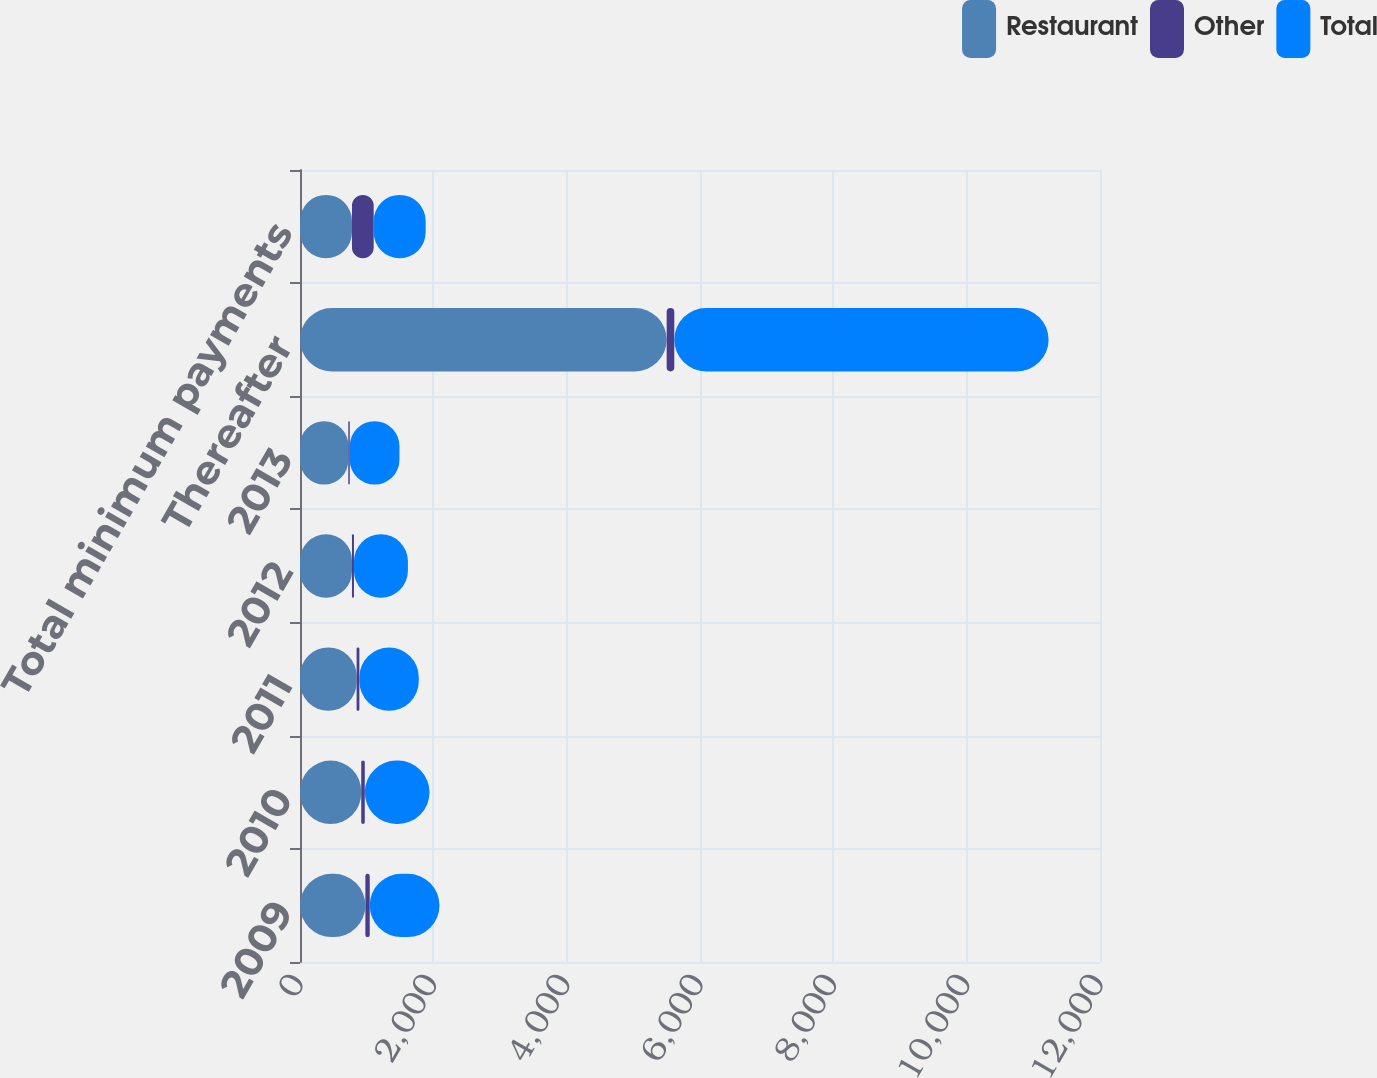<chart> <loc_0><loc_0><loc_500><loc_500><stacked_bar_chart><ecel><fcel>2009<fcel>2010<fcel>2011<fcel>2012<fcel>2013<fcel>Thereafter<fcel>Total minimum payments<nl><fcel>Restaurant<fcel>980.8<fcel>918.7<fcel>849.1<fcel>779.6<fcel>724.5<fcel>5500<fcel>779.6<nl><fcel>Other<fcel>65.3<fcel>52.9<fcel>41.7<fcel>29.8<fcel>21.6<fcel>114.4<fcel>325.7<nl><fcel>Total<fcel>1046.1<fcel>971.6<fcel>890.8<fcel>809.4<fcel>746.1<fcel>5614.4<fcel>779.6<nl></chart> 